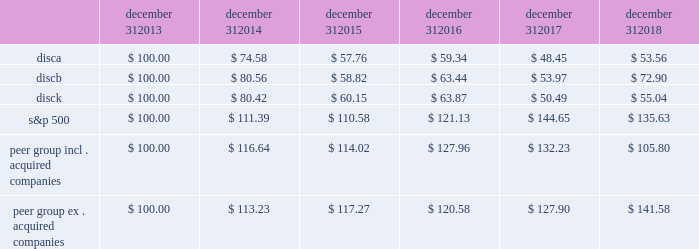Stock performance graph the following graph sets forth the cumulative total shareholder return on our series a common stock , series b common stock and series c common stock as compared with the cumulative total return of the companies listed in the standard and poor 2019s 500 stock index ( 201cs&p 500 index 201d ) and a peer group of companies comprised of cbs corporation class b common stock , scripps network interactive , inc .
( acquired by the company in march 2018 ) , time warner , inc .
( acquired by at&t inc .
In june 2018 ) , twenty-first century fox , inc .
Class a common stock ( news corporation class a common stock prior to june 2013 ) , viacom , inc .
Class b common stock and the walt disney company .
The graph assumes $ 100 originally invested on december 31 , 2013 in each of our series a common stock , series b common stock and series c common stock , the s&p 500 index , and the stock of our peer group companies , including reinvestment of dividends , for the years ended december 31 , 2014 , 2015 , 2016 , 2017 and 2018 .
Two peer companies , scripps networks interactive , inc .
And time warner , inc. , were acquired in 2018 .
The stock performance chart shows the peer group including scripps networks interactive , inc .
And time warner , inc .
And excluding both acquired companies for the entire five year period .
December 31 , december 31 , december 31 , december 31 , december 31 , december 31 .
Equity compensation plan information information regarding securities authorized for issuance under equity compensation plans will be set forth in our definitive proxy statement for our 2019 annual meeting of stockholders under the caption 201csecurities authorized for issuance under equity compensation plans , 201d which is incorporated herein by reference. .
Did the b series stock's 5 year performance beat the s&p 500? 
Computations: (72.90 > 135.63)
Answer: no. 